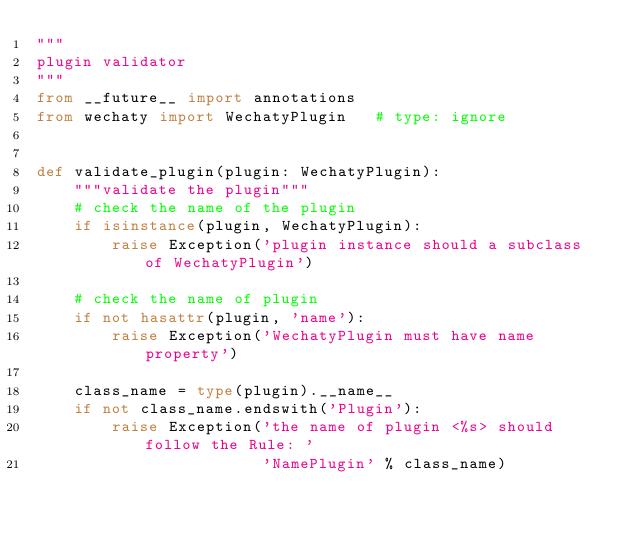<code> <loc_0><loc_0><loc_500><loc_500><_Python_>"""
plugin validator
"""
from __future__ import annotations
from wechaty import WechatyPlugin   # type: ignore


def validate_plugin(plugin: WechatyPlugin):
    """validate the plugin"""
    # check the name of the plugin
    if isinstance(plugin, WechatyPlugin):
        raise Exception('plugin instance should a subclass of WechatyPlugin')

    # check the name of plugin
    if not hasattr(plugin, 'name'):
        raise Exception('WechatyPlugin must have name property')

    class_name = type(plugin).__name__
    if not class_name.endswith('Plugin'):
        raise Exception('the name of plugin <%s> should follow the Rule: '
                        'NamePlugin' % class_name)
</code> 